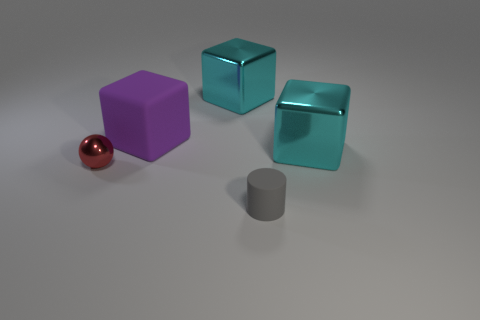Are there any gray objects of the same size as the ball?
Provide a short and direct response. Yes. There is a large cyan object to the left of the object in front of the tiny metal object; what is its material?
Provide a short and direct response. Metal. The object that is the same material as the purple cube is what shape?
Keep it short and to the point. Cylinder. There is a red shiny object left of the cylinder; what size is it?
Keep it short and to the point. Small. Are there the same number of gray cylinders that are left of the tiny matte cylinder and cyan metal cubes that are in front of the big purple object?
Provide a succinct answer. No. There is a metallic cube that is in front of the big cyan object behind the cyan block in front of the large purple matte block; what is its color?
Your answer should be compact. Cyan. How many tiny things are on the right side of the big purple block and behind the cylinder?
Keep it short and to the point. 0. There is a large block that is in front of the large purple rubber block; is its color the same as the large metal block to the left of the small gray matte cylinder?
Offer a very short reply. Yes. Are there any large cyan shiny objects behind the purple object?
Provide a succinct answer. Yes. Are there the same number of big matte things that are to the right of the gray rubber cylinder and large gray rubber cylinders?
Keep it short and to the point. Yes. 